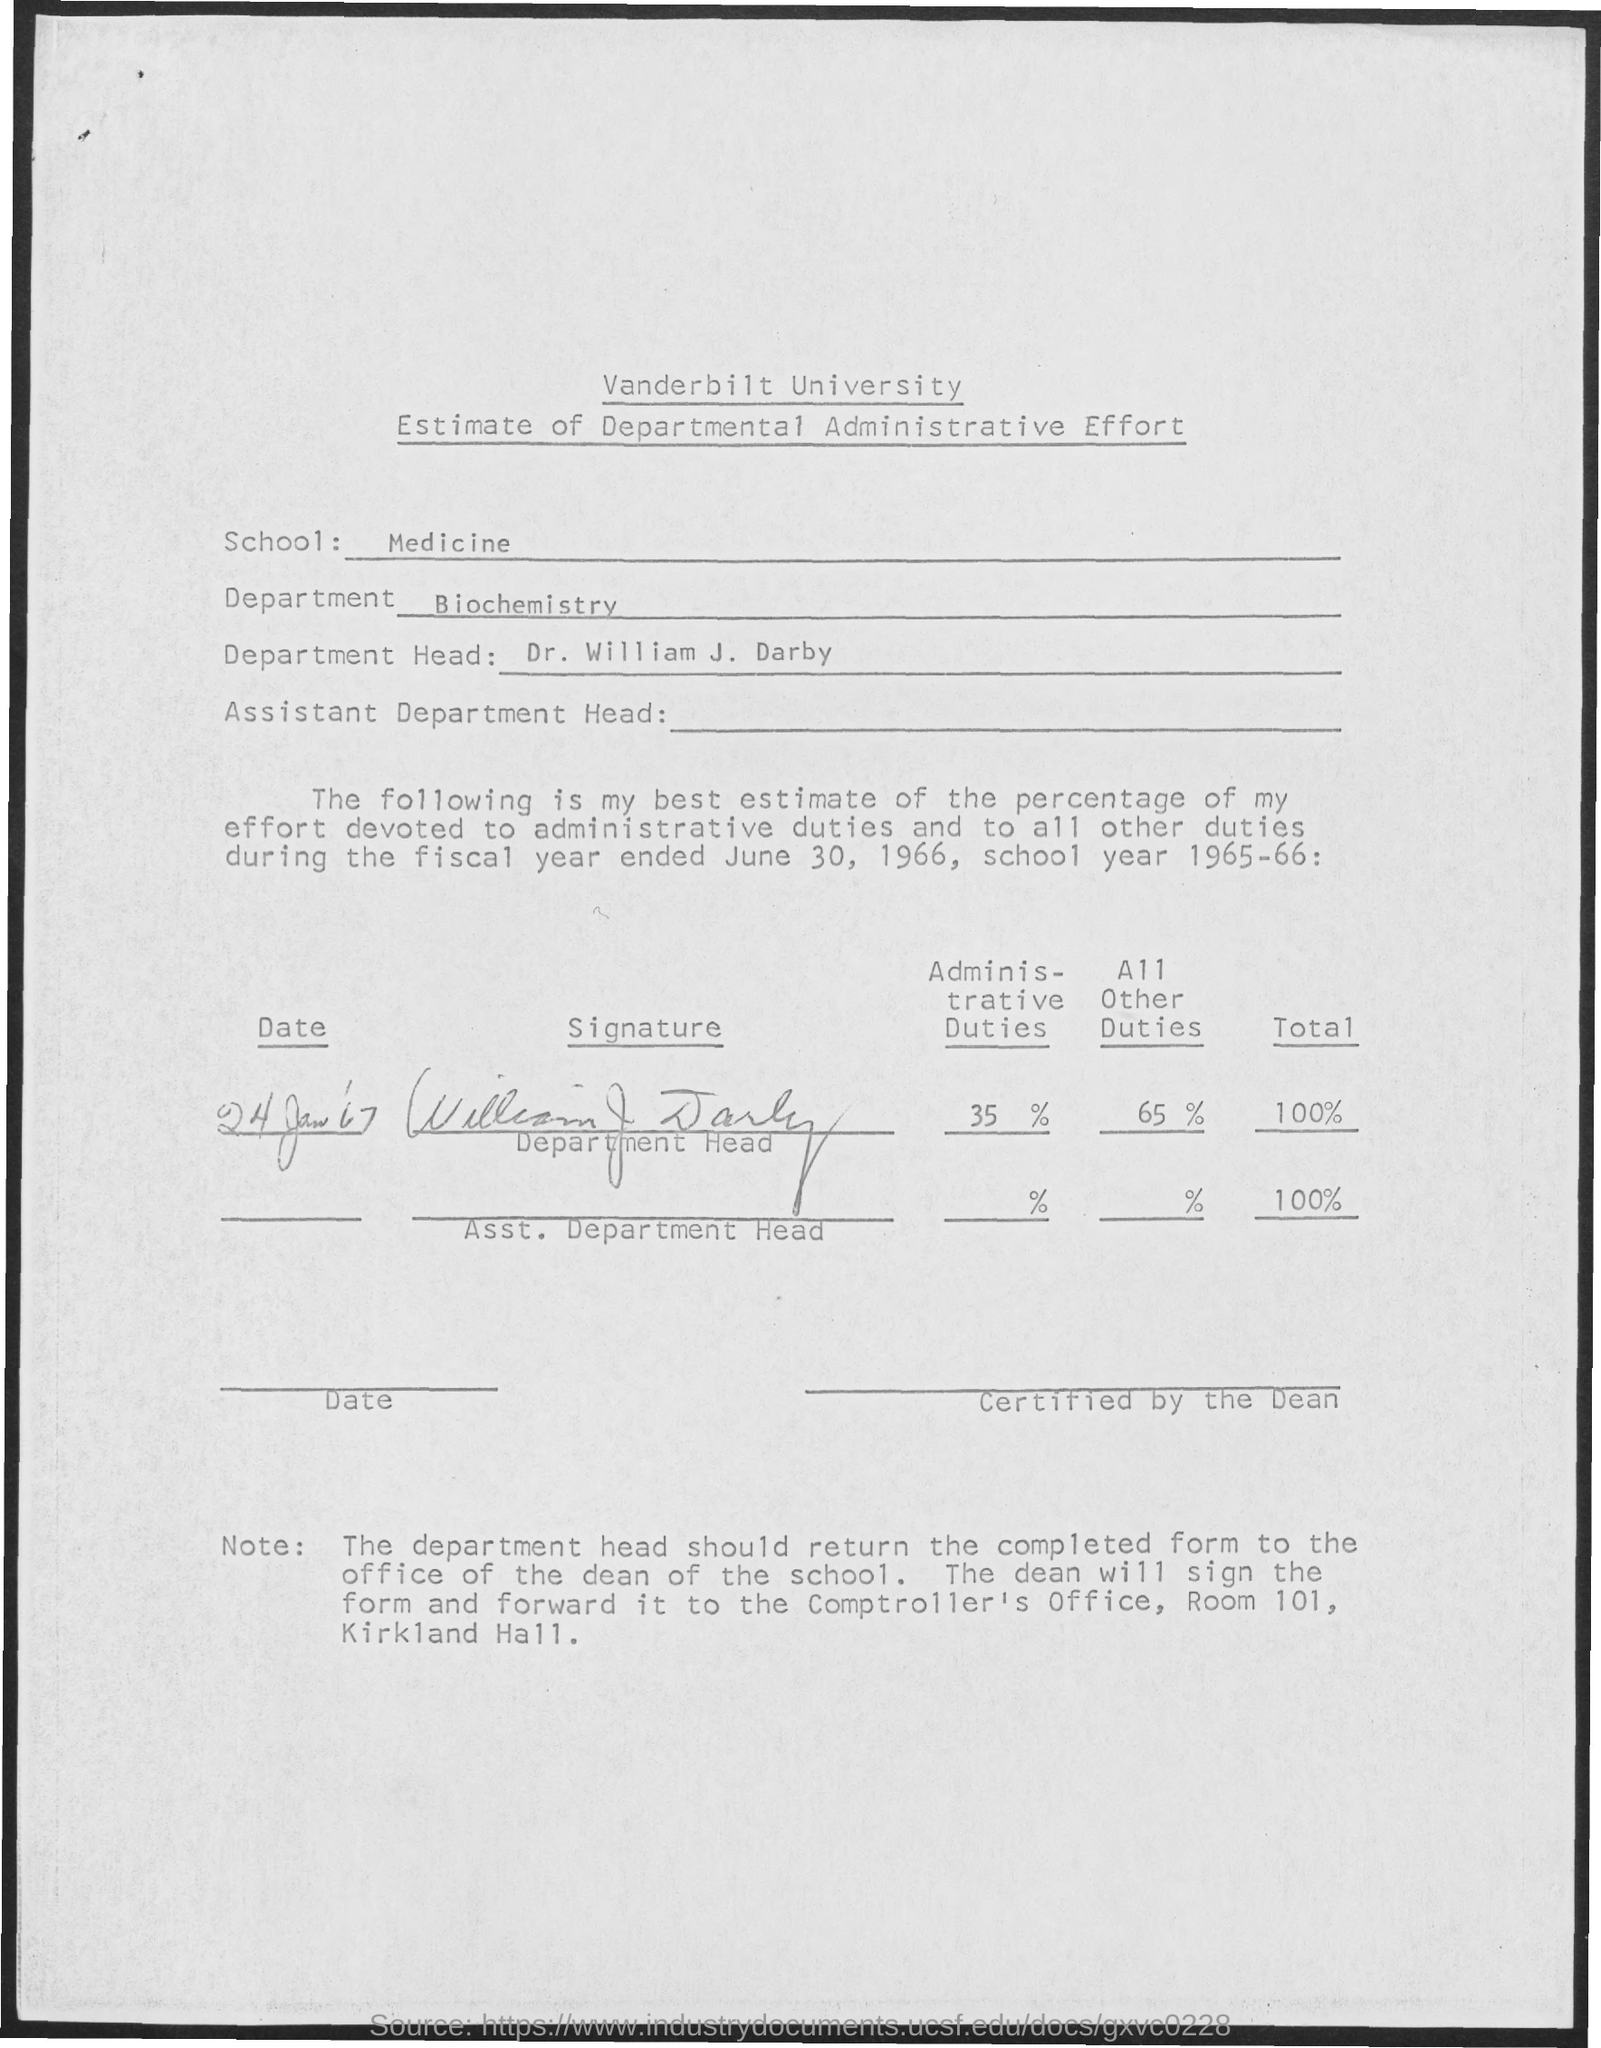Outline some significant characteristics in this image. The name of the department is biochemistry. The head of the University Department is Dr. William J. Darby. 